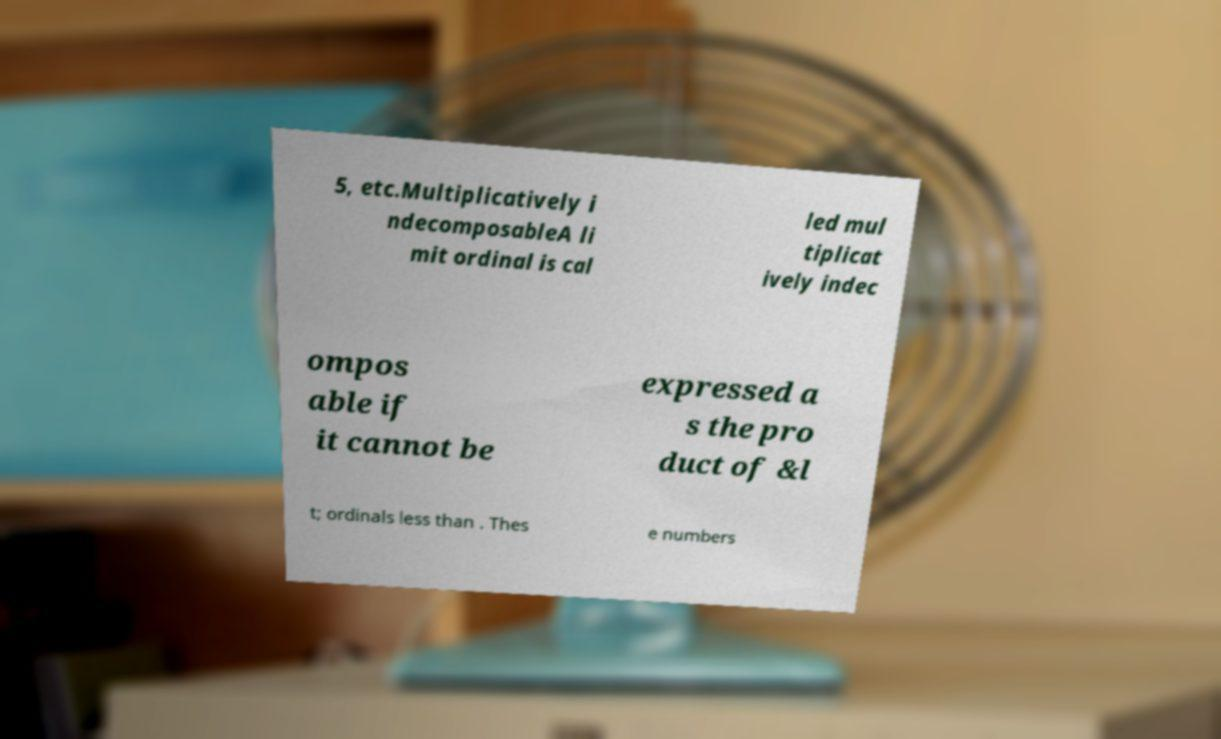What messages or text are displayed in this image? I need them in a readable, typed format. 5, etc.Multiplicatively i ndecomposableA li mit ordinal is cal led mul tiplicat ively indec ompos able if it cannot be expressed a s the pro duct of &l t; ordinals less than . Thes e numbers 